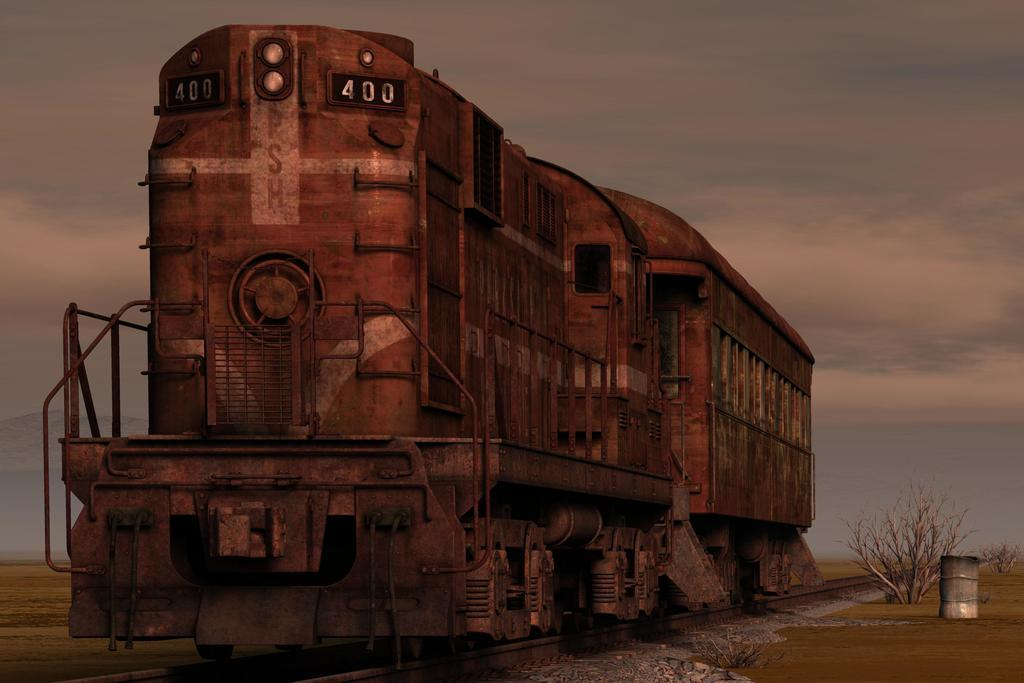What is the main subject of the image? There is a train on the tracks in the image. What type of natural elements can be seen in the image? There are plants visible in the image. What type of terrain is depicted in the image? There are stones in the image. What is visible in the background of the image? The sky is visible in the background of the image. Where is the crowd gathered in the image? There is no crowd present in the image. What type of things are floating in the river in the image? There is no river present in the image. 